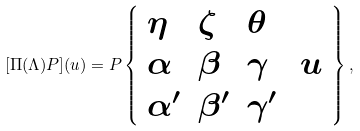<formula> <loc_0><loc_0><loc_500><loc_500>[ \Pi ( \Lambda ) P ] ( u ) = P \left \{ { \begin{array} { l l l l } { \eta } & { \zeta } & { \theta } \\ { \alpha } & { \beta } & { \gamma } & { \, u } \\ { \alpha ^ { \prime } } & { \beta ^ { \prime } } & { \gamma ^ { \prime } } \end{array} } \right \} ,</formula> 